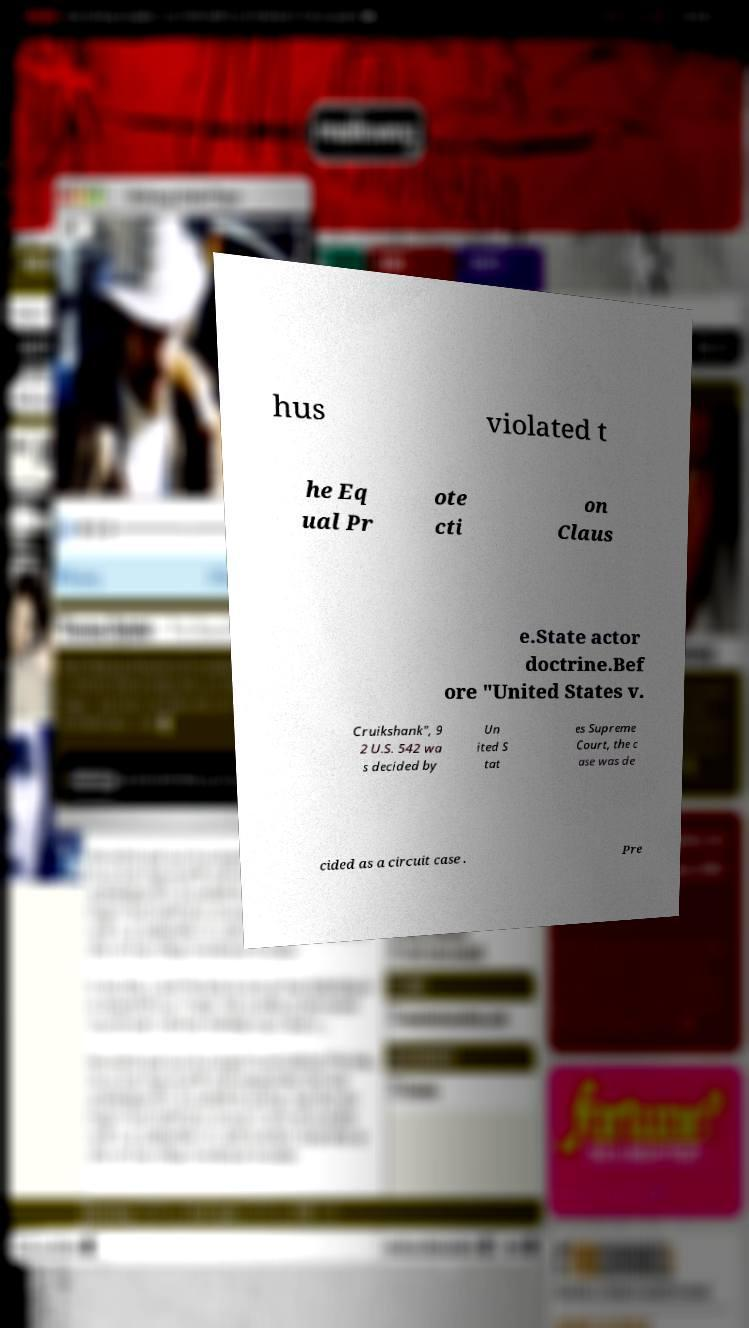I need the written content from this picture converted into text. Can you do that? hus violated t he Eq ual Pr ote cti on Claus e.State actor doctrine.Bef ore "United States v. Cruikshank", 9 2 U.S. 542 wa s decided by Un ited S tat es Supreme Court, the c ase was de cided as a circuit case . Pre 